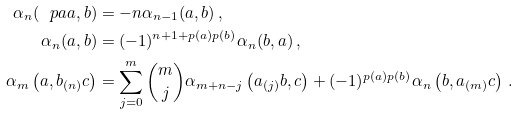<formula> <loc_0><loc_0><loc_500><loc_500>\alpha _ { n } ( \ p a a , b ) & = - n \alpha _ { n - 1 } ( a , b ) \, , \\ \alpha _ { n } ( a , b ) & = ( - 1 ) ^ { n + 1 + p ( a ) p ( b ) } \alpha _ { n } ( b , a ) \, , \\ \alpha _ { m } \left ( a , b _ { ( n ) } c \right ) & = \sum _ { j = 0 } ^ { m } \binom { m } { j } \alpha _ { m + n - j } \left ( a _ { ( j ) } b , c \right ) + ( - 1 ) ^ { p ( a ) p ( b ) } \alpha _ { n } \left ( b , a _ { ( m ) } c \right ) \, .</formula> 